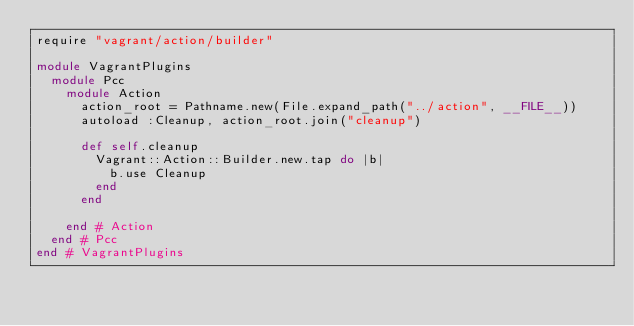Convert code to text. <code><loc_0><loc_0><loc_500><loc_500><_Ruby_>require "vagrant/action/builder"

module VagrantPlugins
  module Pcc
    module Action
      action_root = Pathname.new(File.expand_path("../action", __FILE__))
      autoload :Cleanup, action_root.join("cleanup")

      def self.cleanup
        Vagrant::Action::Builder.new.tap do |b|
          b.use Cleanup
        end
      end

    end # Action
  end # Pcc
end # VagrantPlugins
</code> 